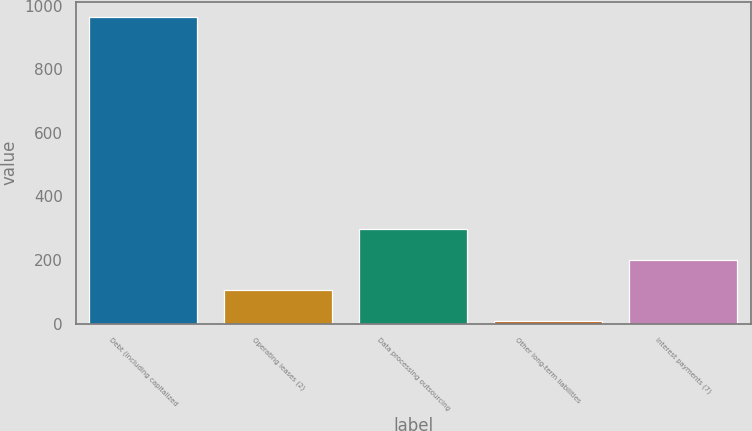Convert chart. <chart><loc_0><loc_0><loc_500><loc_500><bar_chart><fcel>Debt (including capitalized<fcel>Operating leases (2)<fcel>Data processing outsourcing<fcel>Other long-term liabilities<fcel>Interest payments (7)<nl><fcel>965.3<fcel>104.72<fcel>295.96<fcel>9.1<fcel>200.34<nl></chart> 